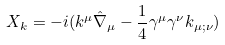Convert formula to latex. <formula><loc_0><loc_0><loc_500><loc_500>X _ { k } = - i ( k ^ { \mu } \hat { \nabla } _ { \mu } - \frac { 1 } { 4 } \gamma ^ { \mu } \gamma ^ { \nu } k _ { \mu ; \nu } )</formula> 